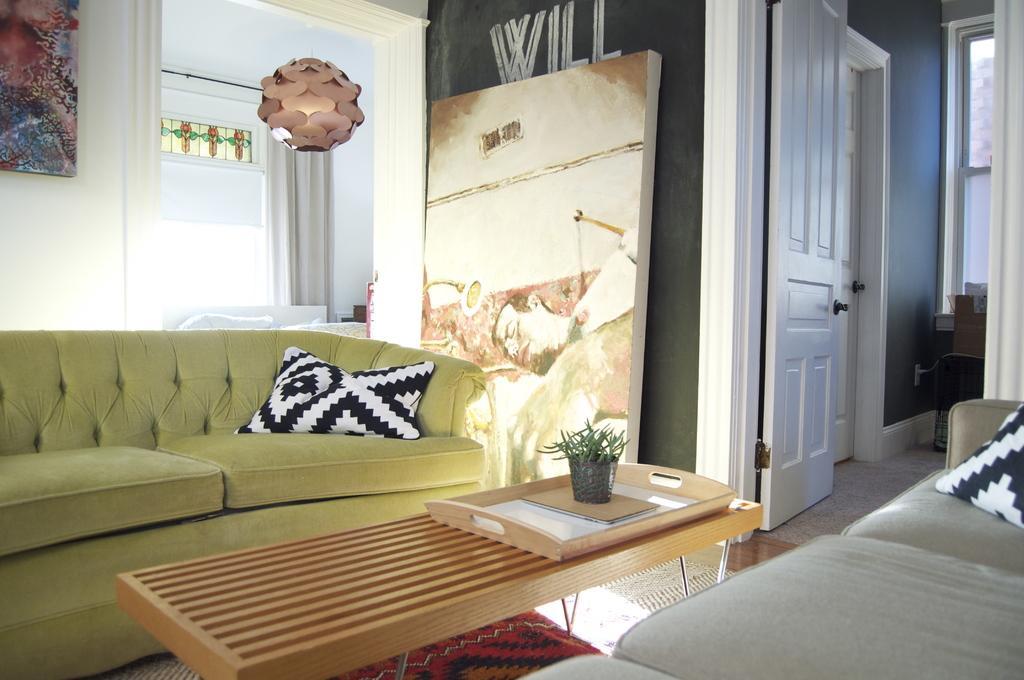Could you give a brief overview of what you see in this image? A picture inside of a room. In this room there is a couch with pillow and a floor with carpet. In-front of this couches there is a table, on this table there is a tray and plant. A painting beside this wall and another painting is on wall. Beside this painting there is a door with handle. Far there is a window. 